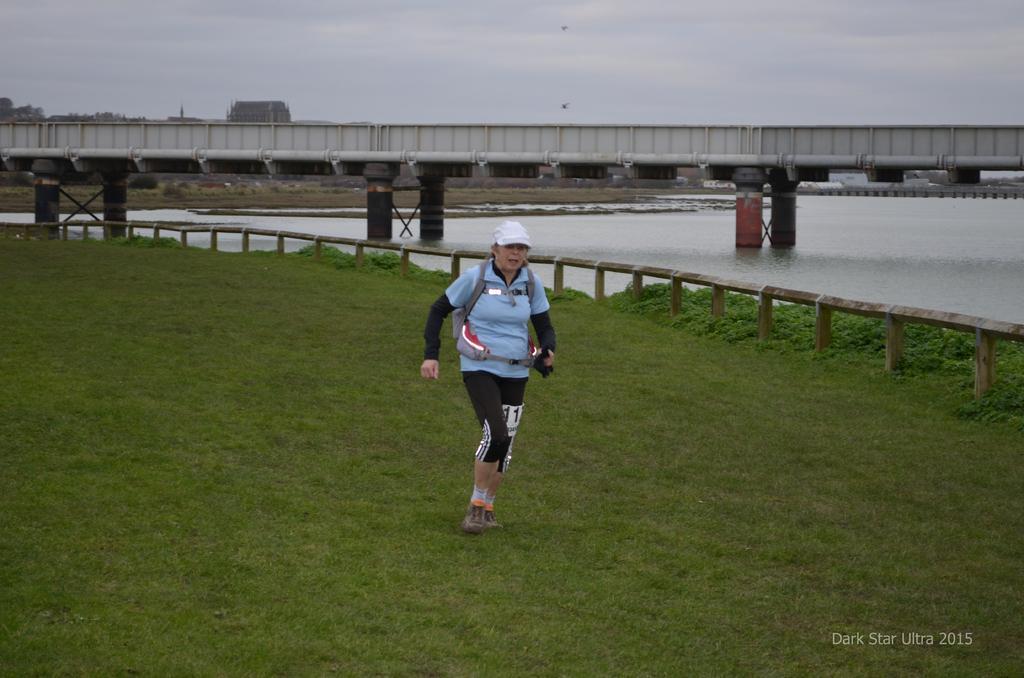Could you give a brief overview of what you see in this image? In this picture, there is a woman running on the grass. She is wearing a blue t shirt, black trousers and carrying a bag. Beside her there is a fence and plants. On the top, there is a bridge. Under it, there is a sea. On the top, there is a sky. 